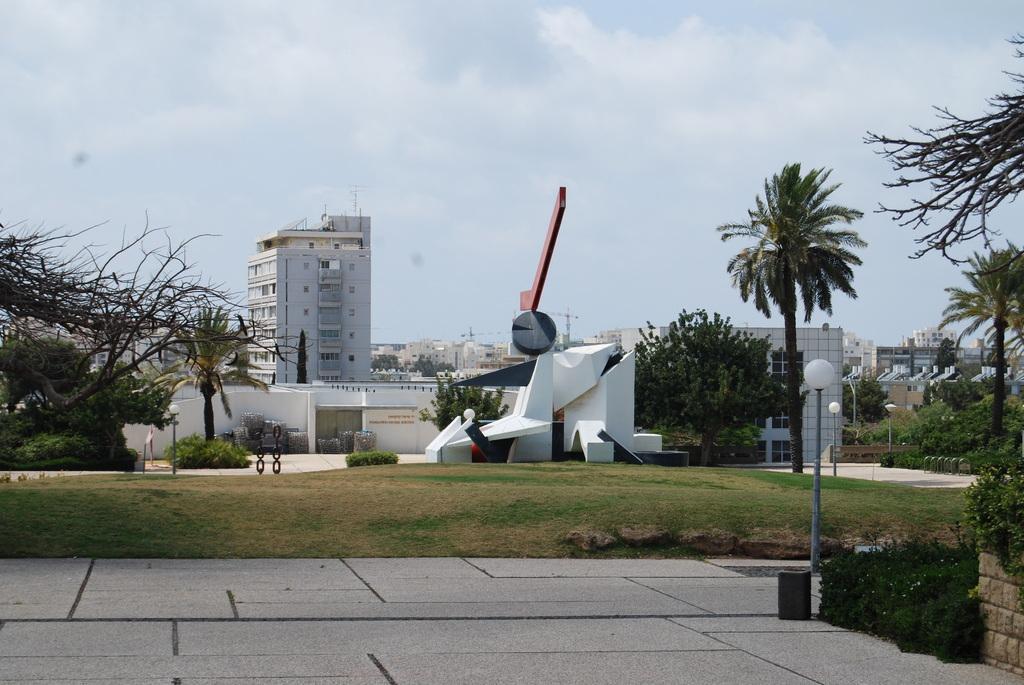Could you give a brief overview of what you see in this image? In this image we can see many buildings, there is a white architecture, there are trees, there are lamps, there is grass, there is sky on the top. 